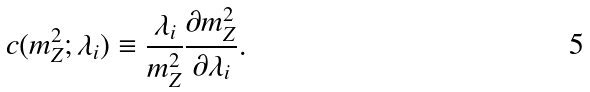<formula> <loc_0><loc_0><loc_500><loc_500>c ( m _ { Z } ^ { 2 } ; \lambda _ { i } ) \equiv \frac { \lambda _ { i } } { m _ { Z } ^ { 2 } } \frac { \partial m _ { Z } ^ { 2 } } { \partial \lambda _ { i } } .</formula> 